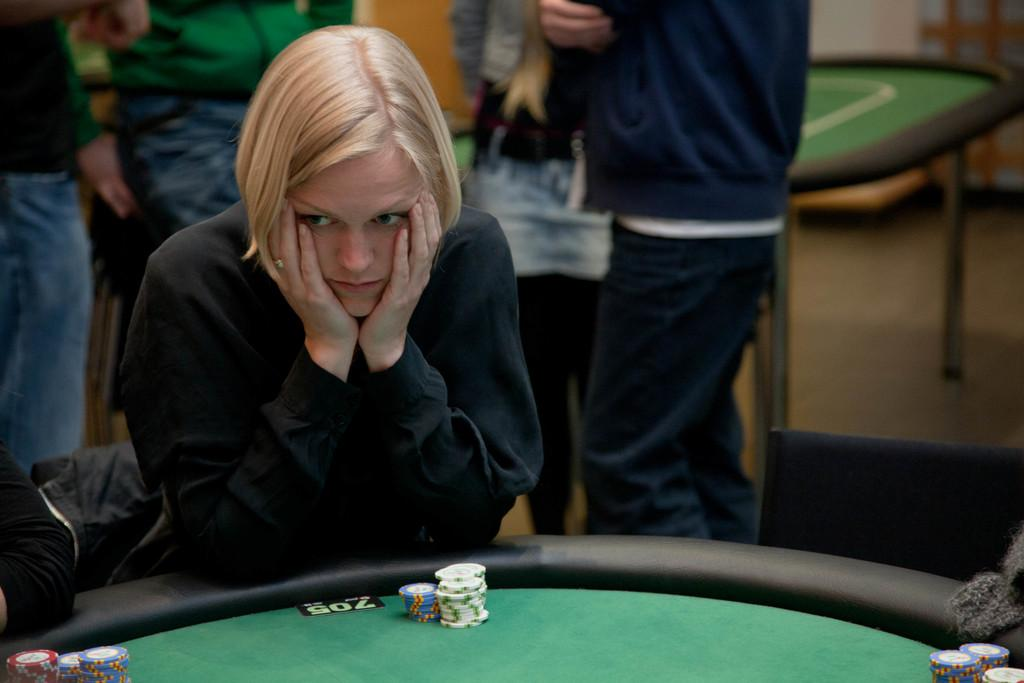What is the woman in the image doing? The woman is playing poker on a table. Can you describe the setting of the image? The woman is seated, and there are people standing in the background of the image. What type of pie is the woman holding in the image? There is no pie present in the image; the woman is playing poker on a table. 